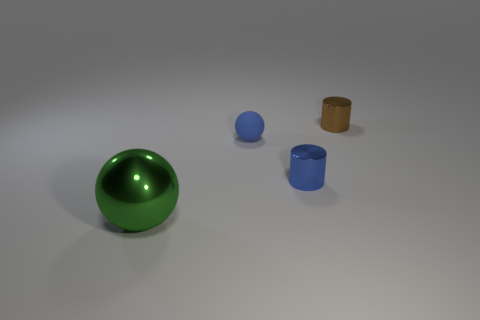What is the size of the shiny object that is both right of the tiny matte ball and in front of the small blue matte ball?
Keep it short and to the point. Small. There is a small metal object that is on the left side of the brown object; is it the same shape as the tiny brown metallic thing?
Your answer should be very brief. Yes. What is the size of the shiny cylinder on the left side of the thing that is on the right side of the small shiny cylinder that is in front of the blue matte object?
Your answer should be very brief. Small. What size is the metallic object that is the same color as the matte ball?
Ensure brevity in your answer.  Small. How many objects are small gray rubber balls or large green objects?
Make the answer very short. 1. What is the shape of the object that is both in front of the small blue matte thing and on the right side of the small blue matte ball?
Offer a very short reply. Cylinder. There is a small rubber thing; is its shape the same as the object that is behind the tiny blue matte ball?
Give a very brief answer. No. Are there any big green shiny objects in front of the large green metallic sphere?
Make the answer very short. No. What is the material of the small cylinder that is the same color as the matte thing?
Keep it short and to the point. Metal. What number of cubes are either purple things or tiny matte objects?
Offer a very short reply. 0. 